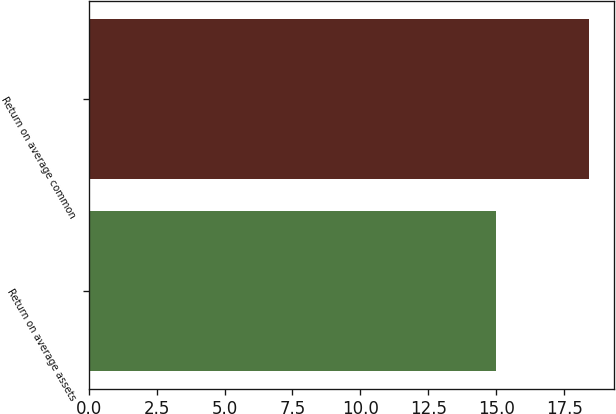Convert chart. <chart><loc_0><loc_0><loc_500><loc_500><bar_chart><fcel>Return on average assets<fcel>Return on average common<nl><fcel>15<fcel>18.4<nl></chart> 